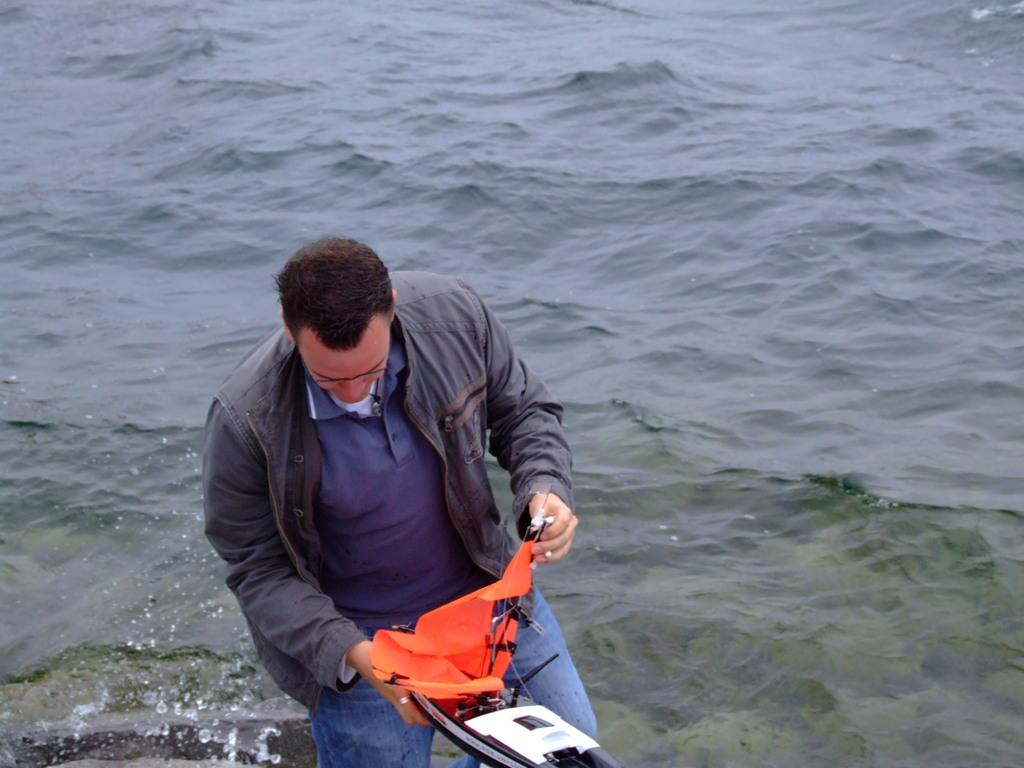What is the main subject of the image? There is a man standing in the image. What is the man holding in his hands? The man is holding an object in his hands. What can be seen in the background of the image? There is water flowing in the image. What design can be seen on the man's toes in the image? There is no information about the man's toes or any design on them in the provided facts, so we cannot answer this question. 